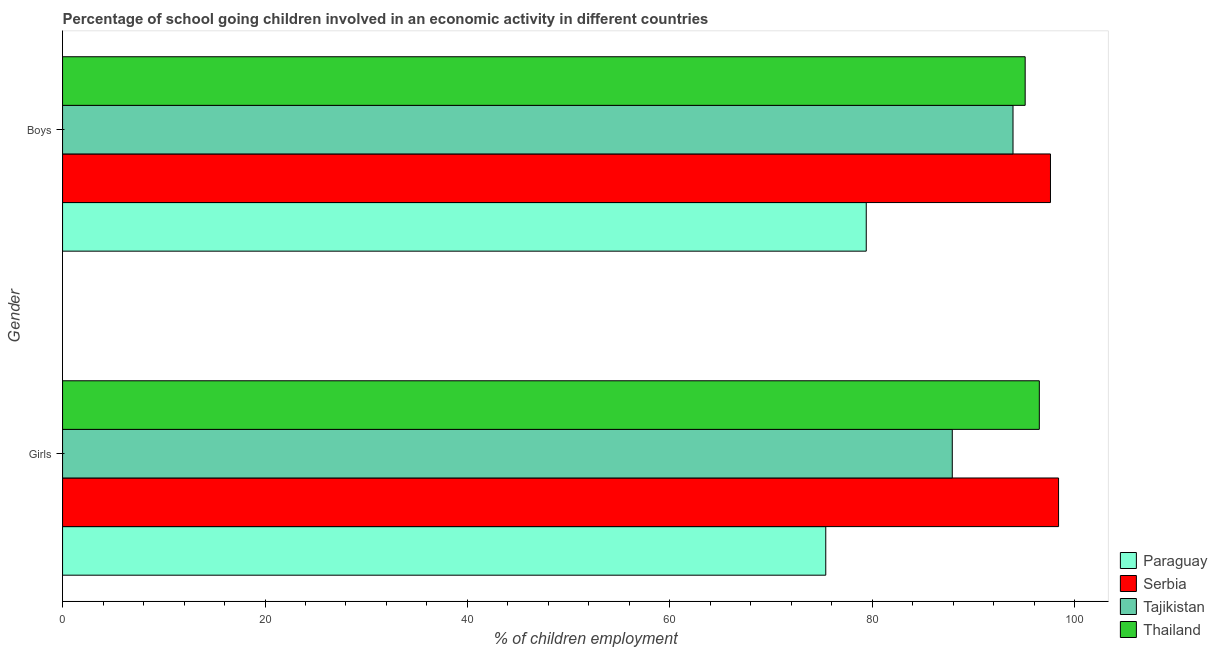How many different coloured bars are there?
Your response must be concise. 4. How many groups of bars are there?
Keep it short and to the point. 2. Are the number of bars per tick equal to the number of legend labels?
Your answer should be very brief. Yes. Are the number of bars on each tick of the Y-axis equal?
Provide a short and direct response. Yes. What is the label of the 1st group of bars from the top?
Offer a very short reply. Boys. What is the percentage of school going girls in Tajikistan?
Give a very brief answer. 87.9. Across all countries, what is the maximum percentage of school going girls?
Ensure brevity in your answer.  98.4. Across all countries, what is the minimum percentage of school going boys?
Keep it short and to the point. 79.4. In which country was the percentage of school going girls maximum?
Your answer should be compact. Serbia. In which country was the percentage of school going boys minimum?
Your response must be concise. Paraguay. What is the total percentage of school going girls in the graph?
Keep it short and to the point. 358.2. What is the average percentage of school going girls per country?
Your answer should be very brief. 89.55. What is the difference between the percentage of school going boys and percentage of school going girls in Tajikistan?
Provide a short and direct response. 6. In how many countries, is the percentage of school going girls greater than 32 %?
Provide a short and direct response. 4. What is the ratio of the percentage of school going girls in Thailand to that in Serbia?
Make the answer very short. 0.98. In how many countries, is the percentage of school going boys greater than the average percentage of school going boys taken over all countries?
Your answer should be very brief. 3. What does the 1st bar from the top in Girls represents?
Keep it short and to the point. Thailand. What does the 4th bar from the bottom in Girls represents?
Keep it short and to the point. Thailand. How many bars are there?
Your answer should be very brief. 8. Are all the bars in the graph horizontal?
Make the answer very short. Yes. What is the difference between two consecutive major ticks on the X-axis?
Provide a succinct answer. 20. Are the values on the major ticks of X-axis written in scientific E-notation?
Give a very brief answer. No. Does the graph contain grids?
Offer a very short reply. No. Where does the legend appear in the graph?
Make the answer very short. Bottom right. How many legend labels are there?
Your response must be concise. 4. How are the legend labels stacked?
Provide a short and direct response. Vertical. What is the title of the graph?
Your answer should be compact. Percentage of school going children involved in an economic activity in different countries. What is the label or title of the X-axis?
Your answer should be compact. % of children employment. What is the label or title of the Y-axis?
Give a very brief answer. Gender. What is the % of children employment of Paraguay in Girls?
Your answer should be very brief. 75.4. What is the % of children employment of Serbia in Girls?
Offer a very short reply. 98.4. What is the % of children employment in Tajikistan in Girls?
Make the answer very short. 87.9. What is the % of children employment of Thailand in Girls?
Keep it short and to the point. 96.5. What is the % of children employment in Paraguay in Boys?
Make the answer very short. 79.4. What is the % of children employment of Serbia in Boys?
Your answer should be very brief. 97.6. What is the % of children employment in Tajikistan in Boys?
Give a very brief answer. 93.9. What is the % of children employment in Thailand in Boys?
Keep it short and to the point. 95.1. Across all Gender, what is the maximum % of children employment of Paraguay?
Offer a terse response. 79.4. Across all Gender, what is the maximum % of children employment in Serbia?
Keep it short and to the point. 98.4. Across all Gender, what is the maximum % of children employment in Tajikistan?
Keep it short and to the point. 93.9. Across all Gender, what is the maximum % of children employment of Thailand?
Provide a short and direct response. 96.5. Across all Gender, what is the minimum % of children employment of Paraguay?
Offer a terse response. 75.4. Across all Gender, what is the minimum % of children employment in Serbia?
Provide a succinct answer. 97.6. Across all Gender, what is the minimum % of children employment in Tajikistan?
Your response must be concise. 87.9. Across all Gender, what is the minimum % of children employment in Thailand?
Give a very brief answer. 95.1. What is the total % of children employment in Paraguay in the graph?
Offer a very short reply. 154.8. What is the total % of children employment of Serbia in the graph?
Provide a short and direct response. 196. What is the total % of children employment in Tajikistan in the graph?
Your response must be concise. 181.8. What is the total % of children employment in Thailand in the graph?
Give a very brief answer. 191.6. What is the difference between the % of children employment of Paraguay in Girls and that in Boys?
Your answer should be compact. -4. What is the difference between the % of children employment in Serbia in Girls and that in Boys?
Your answer should be compact. 0.8. What is the difference between the % of children employment of Thailand in Girls and that in Boys?
Keep it short and to the point. 1.4. What is the difference between the % of children employment in Paraguay in Girls and the % of children employment in Serbia in Boys?
Make the answer very short. -22.2. What is the difference between the % of children employment of Paraguay in Girls and the % of children employment of Tajikistan in Boys?
Ensure brevity in your answer.  -18.5. What is the difference between the % of children employment in Paraguay in Girls and the % of children employment in Thailand in Boys?
Offer a terse response. -19.7. What is the average % of children employment of Paraguay per Gender?
Give a very brief answer. 77.4. What is the average % of children employment in Serbia per Gender?
Give a very brief answer. 98. What is the average % of children employment in Tajikistan per Gender?
Your answer should be compact. 90.9. What is the average % of children employment of Thailand per Gender?
Provide a short and direct response. 95.8. What is the difference between the % of children employment in Paraguay and % of children employment in Tajikistan in Girls?
Make the answer very short. -12.5. What is the difference between the % of children employment of Paraguay and % of children employment of Thailand in Girls?
Ensure brevity in your answer.  -21.1. What is the difference between the % of children employment in Serbia and % of children employment in Tajikistan in Girls?
Provide a short and direct response. 10.5. What is the difference between the % of children employment in Paraguay and % of children employment in Serbia in Boys?
Provide a succinct answer. -18.2. What is the difference between the % of children employment of Paraguay and % of children employment of Tajikistan in Boys?
Your answer should be very brief. -14.5. What is the difference between the % of children employment in Paraguay and % of children employment in Thailand in Boys?
Offer a terse response. -15.7. What is the difference between the % of children employment in Serbia and % of children employment in Tajikistan in Boys?
Your answer should be compact. 3.7. What is the difference between the % of children employment in Tajikistan and % of children employment in Thailand in Boys?
Your response must be concise. -1.2. What is the ratio of the % of children employment of Paraguay in Girls to that in Boys?
Offer a very short reply. 0.95. What is the ratio of the % of children employment in Serbia in Girls to that in Boys?
Your answer should be very brief. 1.01. What is the ratio of the % of children employment in Tajikistan in Girls to that in Boys?
Make the answer very short. 0.94. What is the ratio of the % of children employment of Thailand in Girls to that in Boys?
Give a very brief answer. 1.01. What is the difference between the highest and the second highest % of children employment of Paraguay?
Provide a short and direct response. 4. What is the difference between the highest and the second highest % of children employment of Serbia?
Provide a short and direct response. 0.8. What is the difference between the highest and the second highest % of children employment of Tajikistan?
Ensure brevity in your answer.  6. What is the difference between the highest and the second highest % of children employment in Thailand?
Make the answer very short. 1.4. What is the difference between the highest and the lowest % of children employment of Serbia?
Your answer should be compact. 0.8. What is the difference between the highest and the lowest % of children employment in Tajikistan?
Your answer should be compact. 6. What is the difference between the highest and the lowest % of children employment of Thailand?
Provide a short and direct response. 1.4. 